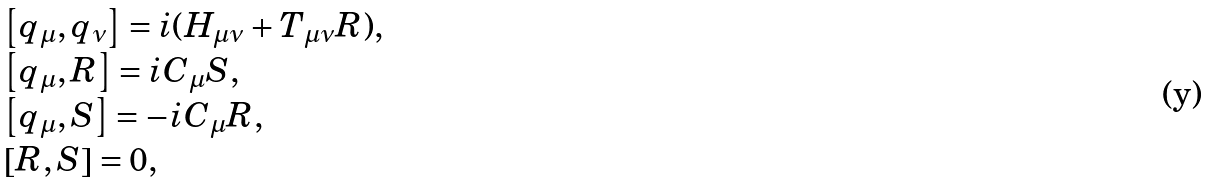<formula> <loc_0><loc_0><loc_500><loc_500>\begin{array} { l } \left [ q _ { \mu } , q _ { \nu } \right ] = i ( H _ { \mu \nu } + T _ { \mu \nu } R ) , \\ \left [ q _ { \mu } , R \right ] = i C _ { \mu } S , \\ \left [ q _ { \mu } , S \right ] = - i C _ { \mu } R , \\ \left [ R , S \right ] = 0 , \end{array}</formula> 